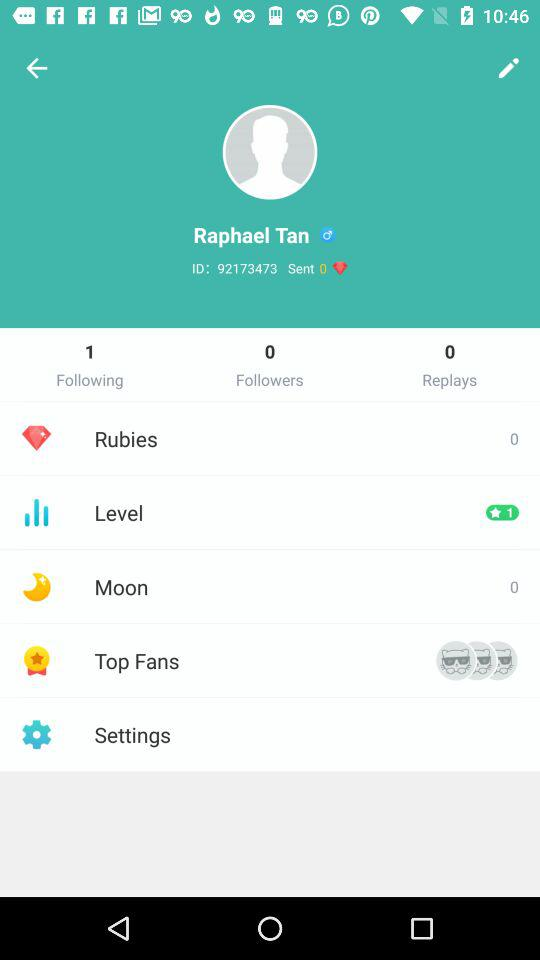How many "Rubies" are there? There are 0 "Rubies". 